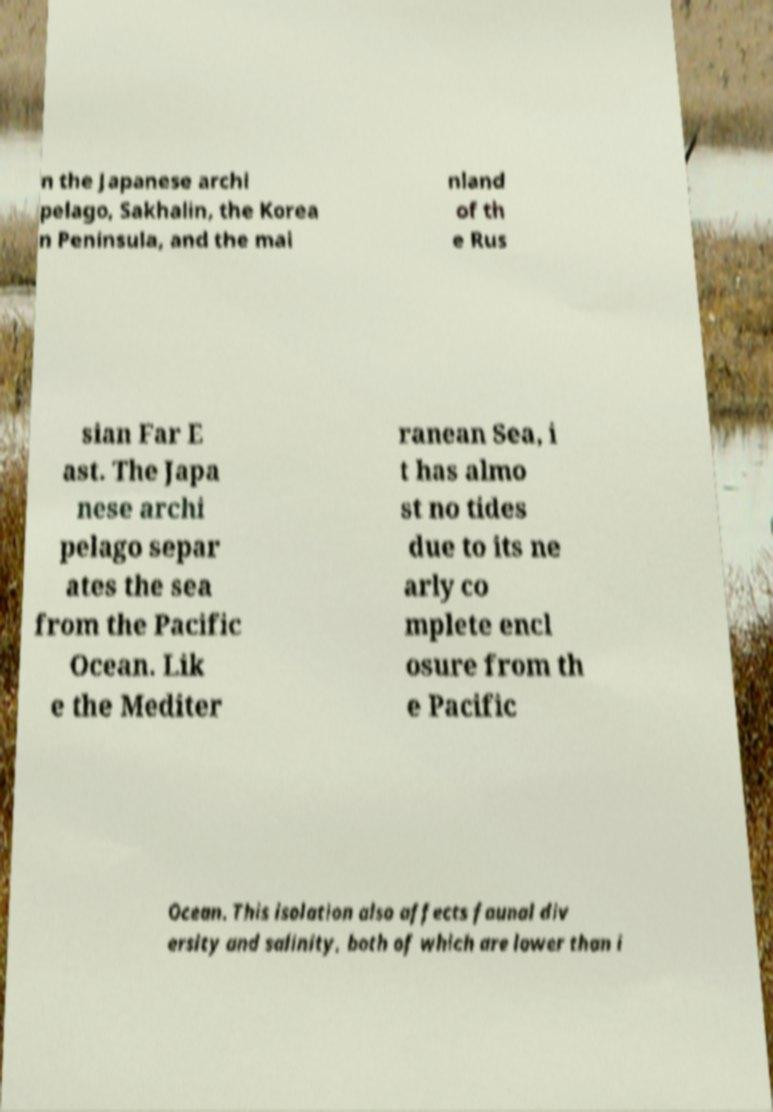Can you read and provide the text displayed in the image?This photo seems to have some interesting text. Can you extract and type it out for me? n the Japanese archi pelago, Sakhalin, the Korea n Peninsula, and the mai nland of th e Rus sian Far E ast. The Japa nese archi pelago separ ates the sea from the Pacific Ocean. Lik e the Mediter ranean Sea, i t has almo st no tides due to its ne arly co mplete encl osure from th e Pacific Ocean. This isolation also affects faunal div ersity and salinity, both of which are lower than i 